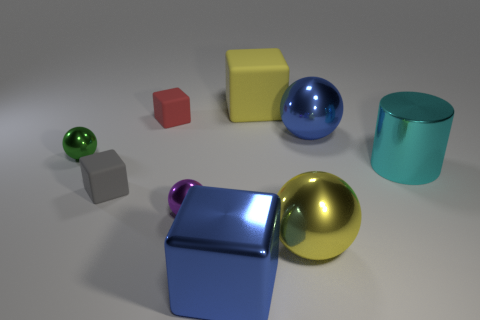How many objects are there in total in this image, and what are their colors? In total, there are seven objects in the image. Their colors are blue, yellow, red, grey, green, gold, and turquoise. 